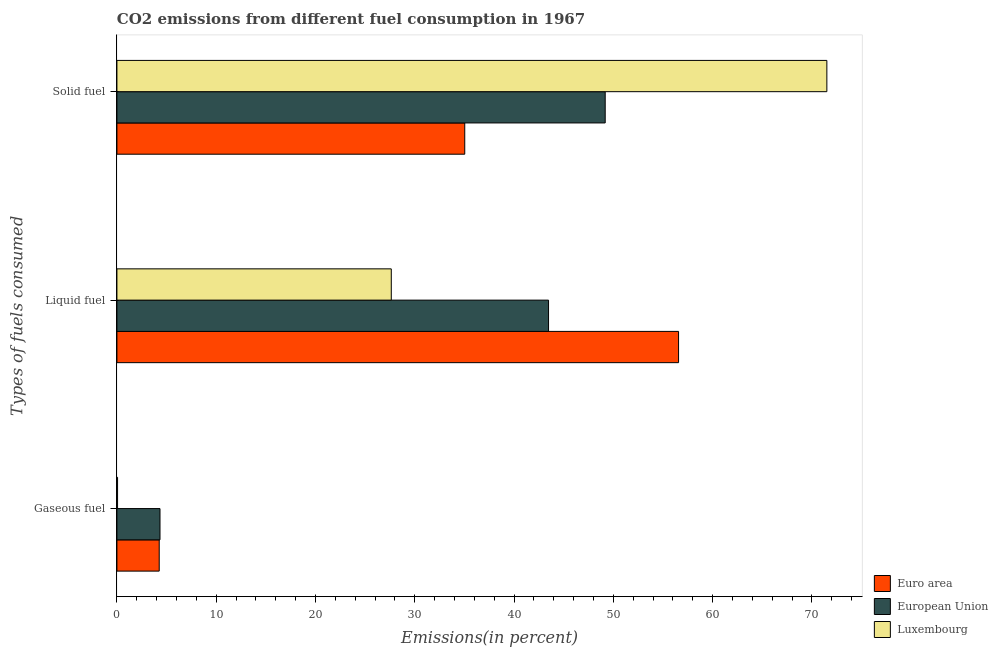Are the number of bars on each tick of the Y-axis equal?
Ensure brevity in your answer.  Yes. What is the label of the 2nd group of bars from the top?
Offer a very short reply. Liquid fuel. What is the percentage of gaseous fuel emission in Euro area?
Your answer should be compact. 4.26. Across all countries, what is the maximum percentage of solid fuel emission?
Offer a terse response. 71.5. Across all countries, what is the minimum percentage of solid fuel emission?
Keep it short and to the point. 35.03. In which country was the percentage of gaseous fuel emission maximum?
Keep it short and to the point. European Union. What is the total percentage of solid fuel emission in the graph?
Your answer should be very brief. 155.7. What is the difference between the percentage of solid fuel emission in Euro area and that in European Union?
Keep it short and to the point. -14.14. What is the difference between the percentage of liquid fuel emission in European Union and the percentage of solid fuel emission in Luxembourg?
Provide a succinct answer. -28.03. What is the average percentage of gaseous fuel emission per country?
Your answer should be very brief. 2.89. What is the difference between the percentage of solid fuel emission and percentage of gaseous fuel emission in Luxembourg?
Offer a terse response. 71.43. What is the ratio of the percentage of solid fuel emission in Luxembourg to that in Euro area?
Provide a short and direct response. 2.04. Is the percentage of gaseous fuel emission in Luxembourg less than that in European Union?
Provide a short and direct response. Yes. Is the difference between the percentage of liquid fuel emission in Luxembourg and Euro area greater than the difference between the percentage of gaseous fuel emission in Luxembourg and Euro area?
Keep it short and to the point. No. What is the difference between the highest and the second highest percentage of gaseous fuel emission?
Make the answer very short. 0.08. What is the difference between the highest and the lowest percentage of gaseous fuel emission?
Your response must be concise. 4.27. What does the 3rd bar from the top in Liquid fuel represents?
Ensure brevity in your answer.  Euro area. What does the 3rd bar from the bottom in Gaseous fuel represents?
Your answer should be very brief. Luxembourg. How many bars are there?
Provide a succinct answer. 9. Are all the bars in the graph horizontal?
Give a very brief answer. Yes. What is the difference between two consecutive major ticks on the X-axis?
Give a very brief answer. 10. Are the values on the major ticks of X-axis written in scientific E-notation?
Offer a very short reply. No. Does the graph contain grids?
Offer a terse response. No. Where does the legend appear in the graph?
Offer a terse response. Bottom right. How are the legend labels stacked?
Make the answer very short. Vertical. What is the title of the graph?
Your answer should be very brief. CO2 emissions from different fuel consumption in 1967. What is the label or title of the X-axis?
Your answer should be very brief. Emissions(in percent). What is the label or title of the Y-axis?
Give a very brief answer. Types of fuels consumed. What is the Emissions(in percent) of Euro area in Gaseous fuel?
Offer a terse response. 4.26. What is the Emissions(in percent) in European Union in Gaseous fuel?
Keep it short and to the point. 4.34. What is the Emissions(in percent) of Luxembourg in Gaseous fuel?
Offer a very short reply. 0.06. What is the Emissions(in percent) in Euro area in Liquid fuel?
Offer a very short reply. 56.56. What is the Emissions(in percent) of European Union in Liquid fuel?
Make the answer very short. 43.47. What is the Emissions(in percent) of Luxembourg in Liquid fuel?
Your answer should be compact. 27.63. What is the Emissions(in percent) in Euro area in Solid fuel?
Provide a succinct answer. 35.03. What is the Emissions(in percent) of European Union in Solid fuel?
Provide a succinct answer. 49.17. What is the Emissions(in percent) in Luxembourg in Solid fuel?
Keep it short and to the point. 71.5. Across all Types of fuels consumed, what is the maximum Emissions(in percent) in Euro area?
Give a very brief answer. 56.56. Across all Types of fuels consumed, what is the maximum Emissions(in percent) of European Union?
Offer a terse response. 49.17. Across all Types of fuels consumed, what is the maximum Emissions(in percent) in Luxembourg?
Ensure brevity in your answer.  71.5. Across all Types of fuels consumed, what is the minimum Emissions(in percent) of Euro area?
Provide a short and direct response. 4.26. Across all Types of fuels consumed, what is the minimum Emissions(in percent) in European Union?
Your response must be concise. 4.34. Across all Types of fuels consumed, what is the minimum Emissions(in percent) of Luxembourg?
Offer a terse response. 0.06. What is the total Emissions(in percent) of Euro area in the graph?
Provide a succinct answer. 95.85. What is the total Emissions(in percent) of European Union in the graph?
Offer a terse response. 96.98. What is the total Emissions(in percent) of Luxembourg in the graph?
Provide a succinct answer. 99.19. What is the difference between the Emissions(in percent) in Euro area in Gaseous fuel and that in Liquid fuel?
Make the answer very short. -52.3. What is the difference between the Emissions(in percent) in European Union in Gaseous fuel and that in Liquid fuel?
Keep it short and to the point. -39.13. What is the difference between the Emissions(in percent) of Luxembourg in Gaseous fuel and that in Liquid fuel?
Offer a very short reply. -27.57. What is the difference between the Emissions(in percent) of Euro area in Gaseous fuel and that in Solid fuel?
Give a very brief answer. -30.77. What is the difference between the Emissions(in percent) of European Union in Gaseous fuel and that in Solid fuel?
Provide a short and direct response. -44.84. What is the difference between the Emissions(in percent) in Luxembourg in Gaseous fuel and that in Solid fuel?
Offer a terse response. -71.43. What is the difference between the Emissions(in percent) in Euro area in Liquid fuel and that in Solid fuel?
Provide a succinct answer. 21.53. What is the difference between the Emissions(in percent) in European Union in Liquid fuel and that in Solid fuel?
Keep it short and to the point. -5.71. What is the difference between the Emissions(in percent) in Luxembourg in Liquid fuel and that in Solid fuel?
Offer a terse response. -43.87. What is the difference between the Emissions(in percent) in Euro area in Gaseous fuel and the Emissions(in percent) in European Union in Liquid fuel?
Ensure brevity in your answer.  -39.21. What is the difference between the Emissions(in percent) in Euro area in Gaseous fuel and the Emissions(in percent) in Luxembourg in Liquid fuel?
Ensure brevity in your answer.  -23.37. What is the difference between the Emissions(in percent) of European Union in Gaseous fuel and the Emissions(in percent) of Luxembourg in Liquid fuel?
Make the answer very short. -23.29. What is the difference between the Emissions(in percent) of Euro area in Gaseous fuel and the Emissions(in percent) of European Union in Solid fuel?
Your answer should be compact. -44.92. What is the difference between the Emissions(in percent) in Euro area in Gaseous fuel and the Emissions(in percent) in Luxembourg in Solid fuel?
Ensure brevity in your answer.  -67.24. What is the difference between the Emissions(in percent) of European Union in Gaseous fuel and the Emissions(in percent) of Luxembourg in Solid fuel?
Provide a succinct answer. -67.16. What is the difference between the Emissions(in percent) in Euro area in Liquid fuel and the Emissions(in percent) in European Union in Solid fuel?
Your response must be concise. 7.39. What is the difference between the Emissions(in percent) in Euro area in Liquid fuel and the Emissions(in percent) in Luxembourg in Solid fuel?
Your response must be concise. -14.93. What is the difference between the Emissions(in percent) in European Union in Liquid fuel and the Emissions(in percent) in Luxembourg in Solid fuel?
Offer a terse response. -28.03. What is the average Emissions(in percent) of Euro area per Types of fuels consumed?
Offer a very short reply. 31.95. What is the average Emissions(in percent) in European Union per Types of fuels consumed?
Your answer should be compact. 32.33. What is the average Emissions(in percent) of Luxembourg per Types of fuels consumed?
Offer a terse response. 33.06. What is the difference between the Emissions(in percent) of Euro area and Emissions(in percent) of European Union in Gaseous fuel?
Give a very brief answer. -0.08. What is the difference between the Emissions(in percent) of Euro area and Emissions(in percent) of Luxembourg in Gaseous fuel?
Provide a succinct answer. 4.19. What is the difference between the Emissions(in percent) of European Union and Emissions(in percent) of Luxembourg in Gaseous fuel?
Your response must be concise. 4.27. What is the difference between the Emissions(in percent) of Euro area and Emissions(in percent) of European Union in Liquid fuel?
Provide a succinct answer. 13.09. What is the difference between the Emissions(in percent) in Euro area and Emissions(in percent) in Luxembourg in Liquid fuel?
Offer a very short reply. 28.93. What is the difference between the Emissions(in percent) of European Union and Emissions(in percent) of Luxembourg in Liquid fuel?
Provide a short and direct response. 15.84. What is the difference between the Emissions(in percent) of Euro area and Emissions(in percent) of European Union in Solid fuel?
Give a very brief answer. -14.14. What is the difference between the Emissions(in percent) in Euro area and Emissions(in percent) in Luxembourg in Solid fuel?
Provide a succinct answer. -36.47. What is the difference between the Emissions(in percent) in European Union and Emissions(in percent) in Luxembourg in Solid fuel?
Give a very brief answer. -22.32. What is the ratio of the Emissions(in percent) in Euro area in Gaseous fuel to that in Liquid fuel?
Ensure brevity in your answer.  0.08. What is the ratio of the Emissions(in percent) in European Union in Gaseous fuel to that in Liquid fuel?
Your response must be concise. 0.1. What is the ratio of the Emissions(in percent) in Luxembourg in Gaseous fuel to that in Liquid fuel?
Make the answer very short. 0. What is the ratio of the Emissions(in percent) of Euro area in Gaseous fuel to that in Solid fuel?
Your answer should be very brief. 0.12. What is the ratio of the Emissions(in percent) in European Union in Gaseous fuel to that in Solid fuel?
Offer a very short reply. 0.09. What is the ratio of the Emissions(in percent) in Luxembourg in Gaseous fuel to that in Solid fuel?
Your answer should be very brief. 0. What is the ratio of the Emissions(in percent) in Euro area in Liquid fuel to that in Solid fuel?
Offer a very short reply. 1.61. What is the ratio of the Emissions(in percent) in European Union in Liquid fuel to that in Solid fuel?
Keep it short and to the point. 0.88. What is the ratio of the Emissions(in percent) in Luxembourg in Liquid fuel to that in Solid fuel?
Keep it short and to the point. 0.39. What is the difference between the highest and the second highest Emissions(in percent) of Euro area?
Make the answer very short. 21.53. What is the difference between the highest and the second highest Emissions(in percent) in European Union?
Your answer should be compact. 5.71. What is the difference between the highest and the second highest Emissions(in percent) of Luxembourg?
Provide a short and direct response. 43.87. What is the difference between the highest and the lowest Emissions(in percent) in Euro area?
Ensure brevity in your answer.  52.3. What is the difference between the highest and the lowest Emissions(in percent) of European Union?
Make the answer very short. 44.84. What is the difference between the highest and the lowest Emissions(in percent) of Luxembourg?
Offer a very short reply. 71.43. 